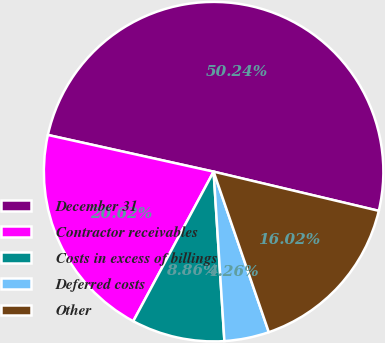<chart> <loc_0><loc_0><loc_500><loc_500><pie_chart><fcel>December 31<fcel>Contractor receivables<fcel>Costs in excess of billings<fcel>Deferred costs<fcel>Other<nl><fcel>50.24%<fcel>20.62%<fcel>8.86%<fcel>4.26%<fcel>16.02%<nl></chart> 